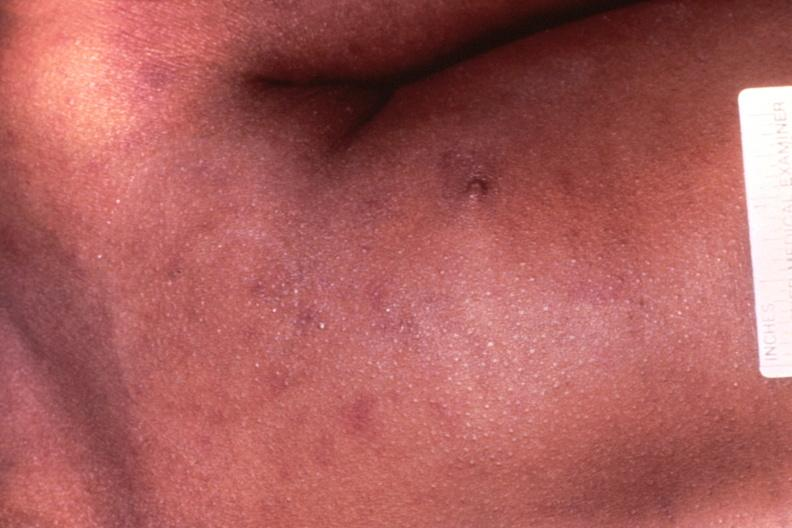what does this image show?
Answer the question using a single word or phrase. Meningococcemia 